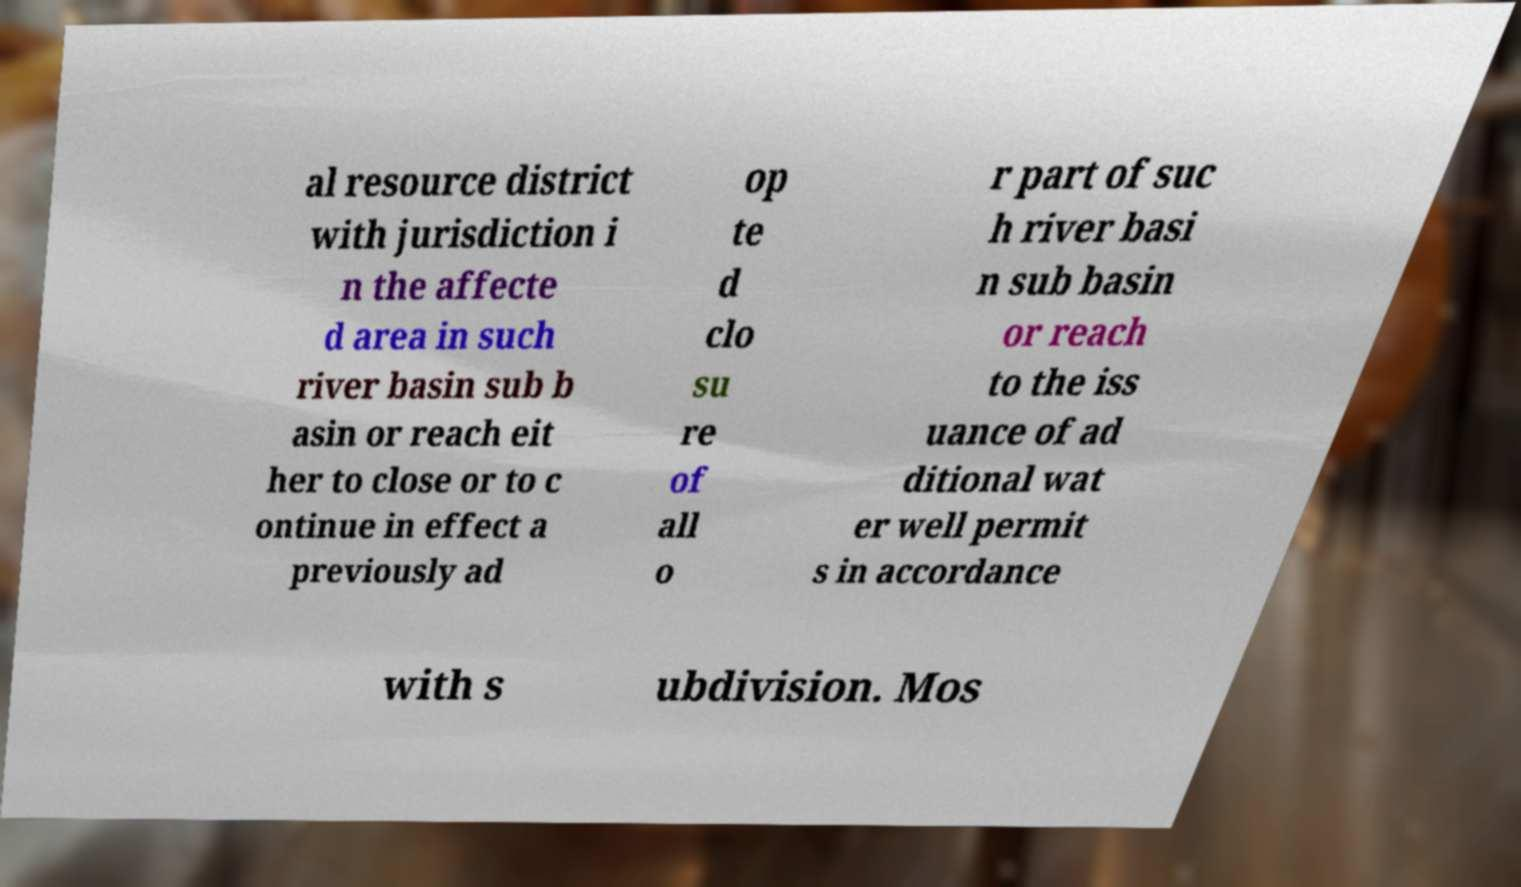There's text embedded in this image that I need extracted. Can you transcribe it verbatim? al resource district with jurisdiction i n the affecte d area in such river basin sub b asin or reach eit her to close or to c ontinue in effect a previously ad op te d clo su re of all o r part of suc h river basi n sub basin or reach to the iss uance of ad ditional wat er well permit s in accordance with s ubdivision. Mos 